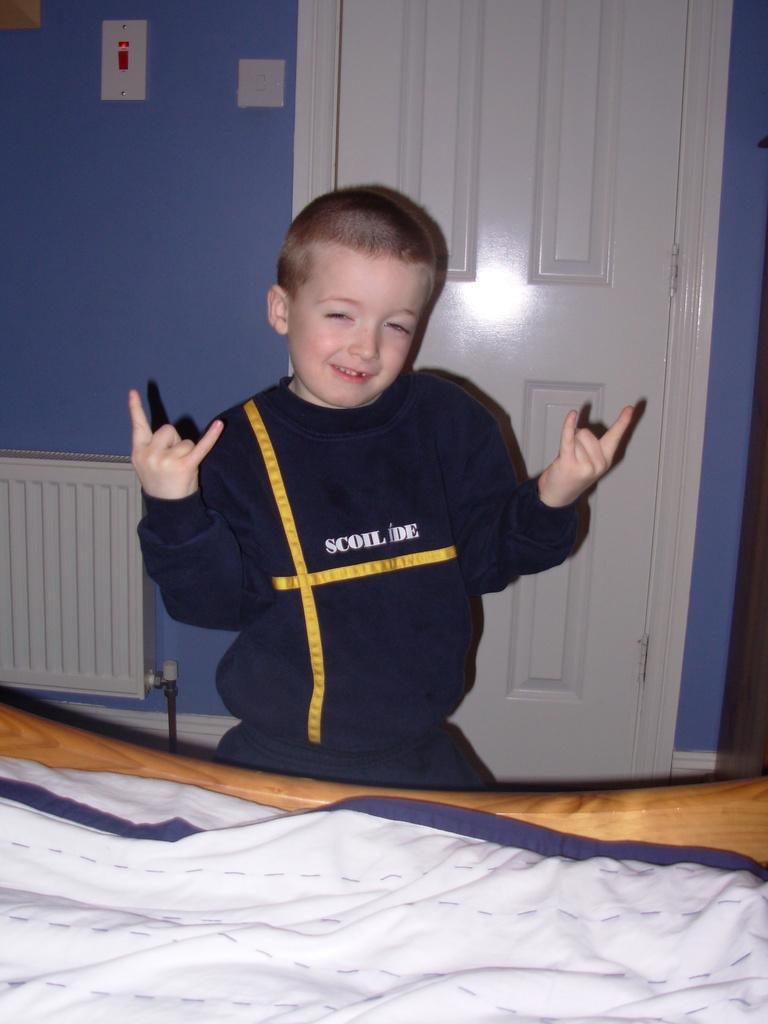Provide a one-sentence caption for the provided image. a boy in a Scoil Ide shirt with devil horn hands. 